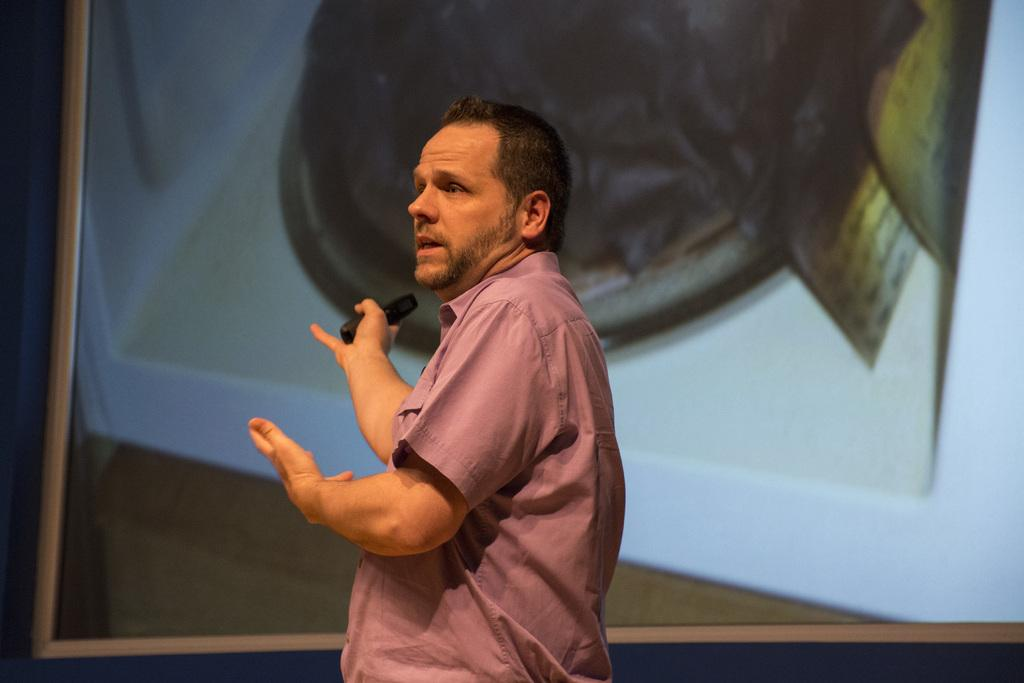Who is the main subject in the image? There is a man in the center of the image. What is located in the background of the image? There is a projector screen in the background of the image. What type of music can be heard coming from the rose in the image? There is no rose or music present in the image. 